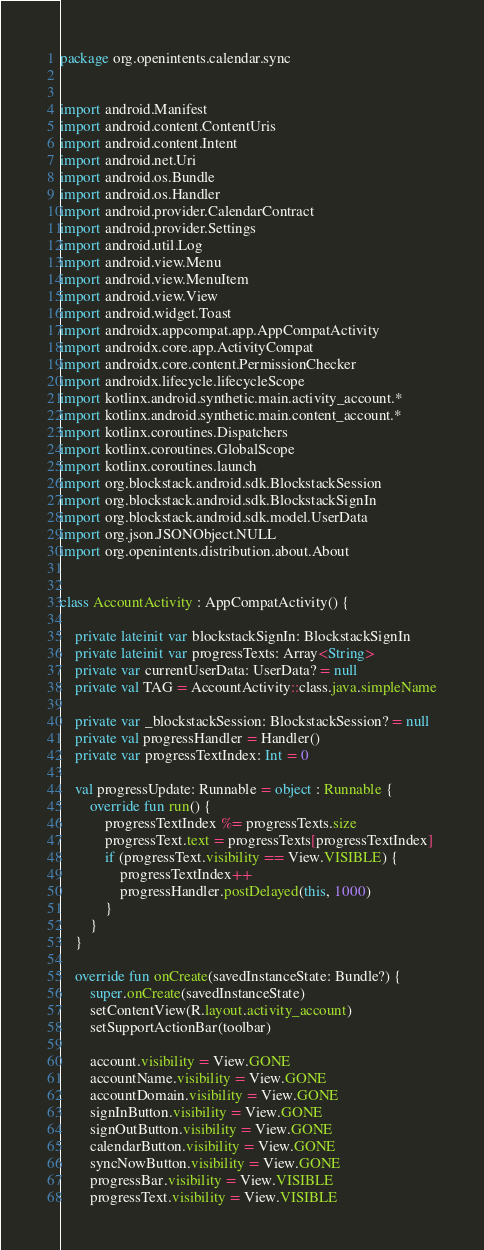<code> <loc_0><loc_0><loc_500><loc_500><_Kotlin_>package org.openintents.calendar.sync


import android.Manifest
import android.content.ContentUris
import android.content.Intent
import android.net.Uri
import android.os.Bundle
import android.os.Handler
import android.provider.CalendarContract
import android.provider.Settings
import android.util.Log
import android.view.Menu
import android.view.MenuItem
import android.view.View
import android.widget.Toast
import androidx.appcompat.app.AppCompatActivity
import androidx.core.app.ActivityCompat
import androidx.core.content.PermissionChecker
import androidx.lifecycle.lifecycleScope
import kotlinx.android.synthetic.main.activity_account.*
import kotlinx.android.synthetic.main.content_account.*
import kotlinx.coroutines.Dispatchers
import kotlinx.coroutines.GlobalScope
import kotlinx.coroutines.launch
import org.blockstack.android.sdk.BlockstackSession
import org.blockstack.android.sdk.BlockstackSignIn
import org.blockstack.android.sdk.model.UserData
import org.json.JSONObject.NULL
import org.openintents.distribution.about.About


class AccountActivity : AppCompatActivity() {

    private lateinit var blockstackSignIn: BlockstackSignIn
    private lateinit var progressTexts: Array<String>
    private var currentUserData: UserData? = null
    private val TAG = AccountActivity::class.java.simpleName

    private var _blockstackSession: BlockstackSession? = null
    private val progressHandler = Handler()
    private var progressTextIndex: Int = 0

    val progressUpdate: Runnable = object : Runnable {
        override fun run() {
            progressTextIndex %= progressTexts.size
            progressText.text = progressTexts[progressTextIndex]
            if (progressText.visibility == View.VISIBLE) {
                progressTextIndex++
                progressHandler.postDelayed(this, 1000)
            }
        }
    }

    override fun onCreate(savedInstanceState: Bundle?) {
        super.onCreate(savedInstanceState)
        setContentView(R.layout.activity_account)
        setSupportActionBar(toolbar)

        account.visibility = View.GONE
        accountName.visibility = View.GONE
        accountDomain.visibility = View.GONE
        signInButton.visibility = View.GONE
        signOutButton.visibility = View.GONE
        calendarButton.visibility = View.GONE
        syncNowButton.visibility = View.GONE
        progressBar.visibility = View.VISIBLE
        progressText.visibility = View.VISIBLE</code> 